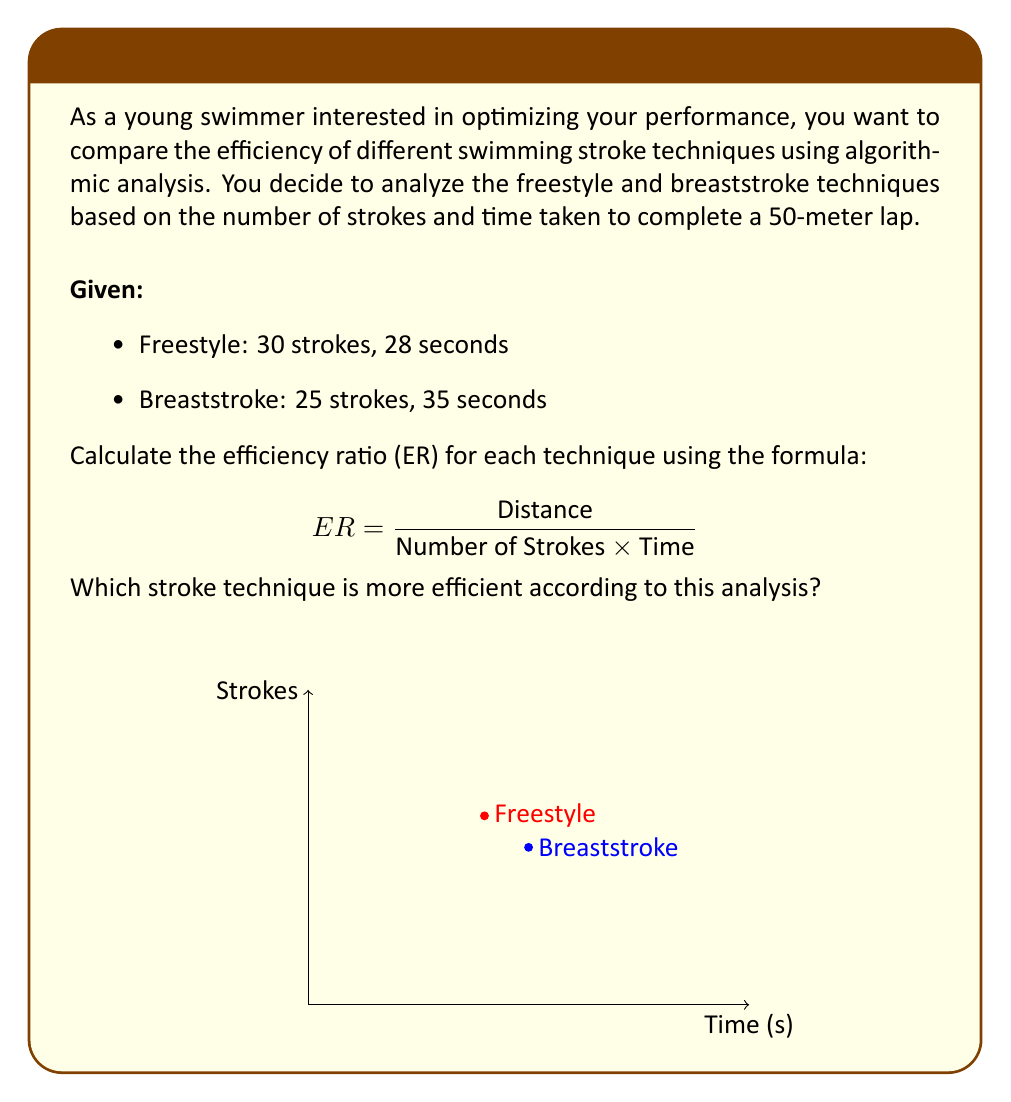Show me your answer to this math problem. Let's solve this problem step by step:

1. Define the formula for Efficiency Ratio (ER):
   $$ ER = \frac{\text{Distance}}{\text{Number of Strokes} \times \text{Time}} $$

2. Calculate ER for Freestyle:
   $$ ER_{\text{Freestyle}} = \frac{50 \text{ m}}{30 \text{ strokes} \times 28 \text{ s}} = \frac{50}{840} \approx 0.0595 \text{ m/(stroke·s)} $$

3. Calculate ER for Breaststroke:
   $$ ER_{\text{Breaststroke}} = \frac{50 \text{ m}}{25 \text{ strokes} \times 35 \text{ s}} = \frac{50}{875} \approx 0.0571 \text{ m/(stroke·s)} $$

4. Compare the efficiency ratios:
   Freestyle ER: 0.0595 m/(stroke·s)
   Breaststroke ER: 0.0571 m/(stroke·s)

5. Interpret the results:
   The higher efficiency ratio indicates a more efficient technique. In this case, the freestyle technique has a higher efficiency ratio (0.0595 > 0.0571).
Answer: Freestyle (ER ≈ 0.0595 m/(stroke·s)) 